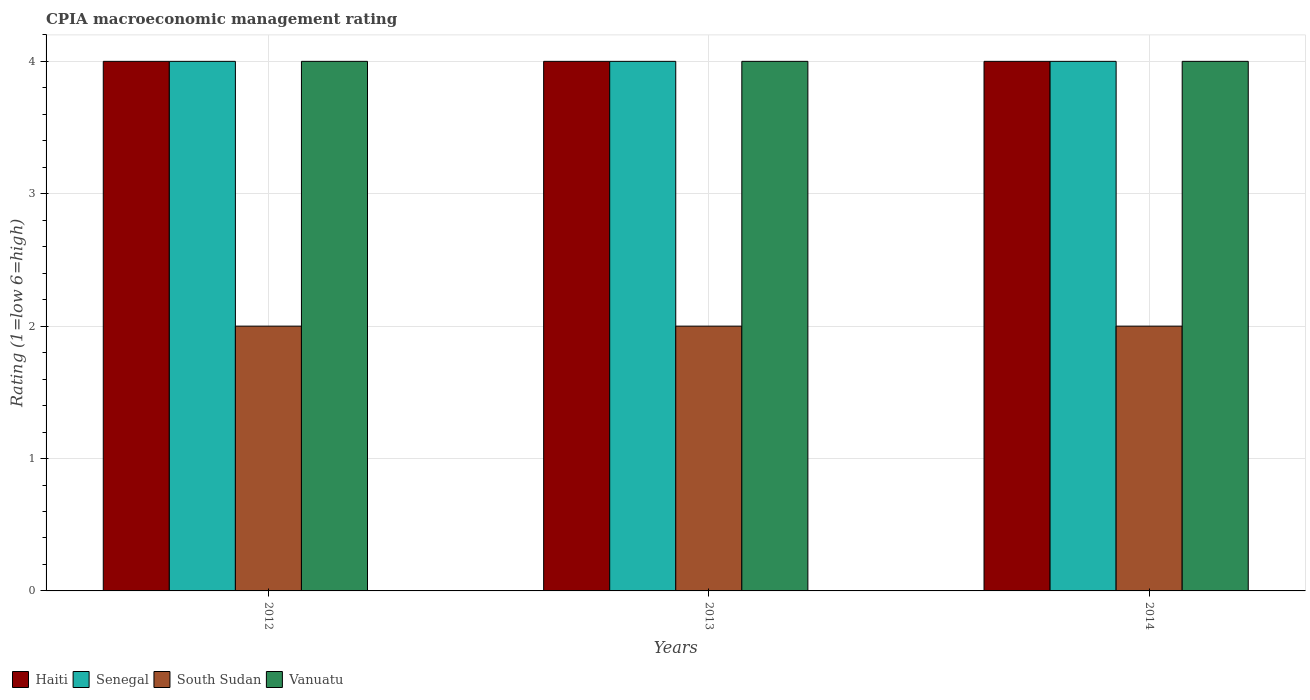Are the number of bars on each tick of the X-axis equal?
Provide a short and direct response. Yes. How many bars are there on the 2nd tick from the left?
Give a very brief answer. 4. In which year was the CPIA rating in Haiti maximum?
Provide a short and direct response. 2012. What is the total CPIA rating in Vanuatu in the graph?
Offer a terse response. 12. What is the average CPIA rating in Haiti per year?
Offer a very short reply. 4. In the year 2012, what is the difference between the CPIA rating in Haiti and CPIA rating in Senegal?
Provide a short and direct response. 0. What is the ratio of the CPIA rating in Haiti in 2012 to that in 2014?
Make the answer very short. 1. Is the CPIA rating in South Sudan in 2013 less than that in 2014?
Offer a terse response. No. Is the difference between the CPIA rating in Haiti in 2012 and 2014 greater than the difference between the CPIA rating in Senegal in 2012 and 2014?
Offer a terse response. No. What is the difference between the highest and the lowest CPIA rating in Vanuatu?
Make the answer very short. 0. In how many years, is the CPIA rating in Senegal greater than the average CPIA rating in Senegal taken over all years?
Offer a terse response. 0. Is the sum of the CPIA rating in South Sudan in 2012 and 2014 greater than the maximum CPIA rating in Haiti across all years?
Provide a succinct answer. No. What does the 1st bar from the left in 2014 represents?
Keep it short and to the point. Haiti. What does the 1st bar from the right in 2013 represents?
Your answer should be compact. Vanuatu. How many years are there in the graph?
Give a very brief answer. 3. Does the graph contain any zero values?
Give a very brief answer. No. Does the graph contain grids?
Give a very brief answer. Yes. How are the legend labels stacked?
Provide a short and direct response. Horizontal. What is the title of the graph?
Offer a very short reply. CPIA macroeconomic management rating. What is the label or title of the X-axis?
Offer a very short reply. Years. What is the label or title of the Y-axis?
Make the answer very short. Rating (1=low 6=high). What is the Rating (1=low 6=high) of Haiti in 2012?
Ensure brevity in your answer.  4. What is the Rating (1=low 6=high) in South Sudan in 2012?
Provide a succinct answer. 2. What is the Rating (1=low 6=high) of South Sudan in 2013?
Provide a short and direct response. 2. What is the Rating (1=low 6=high) of Vanuatu in 2013?
Ensure brevity in your answer.  4. What is the Rating (1=low 6=high) of Senegal in 2014?
Provide a short and direct response. 4. What is the Rating (1=low 6=high) of South Sudan in 2014?
Provide a short and direct response. 2. Across all years, what is the maximum Rating (1=low 6=high) of Vanuatu?
Your answer should be compact. 4. Across all years, what is the minimum Rating (1=low 6=high) of Senegal?
Provide a succinct answer. 4. Across all years, what is the minimum Rating (1=low 6=high) in South Sudan?
Your answer should be compact. 2. What is the total Rating (1=low 6=high) of Haiti in the graph?
Provide a succinct answer. 12. What is the total Rating (1=low 6=high) of South Sudan in the graph?
Keep it short and to the point. 6. What is the difference between the Rating (1=low 6=high) in Haiti in 2012 and that in 2013?
Your answer should be compact. 0. What is the difference between the Rating (1=low 6=high) in South Sudan in 2012 and that in 2013?
Your response must be concise. 0. What is the difference between the Rating (1=low 6=high) of Vanuatu in 2012 and that in 2013?
Your response must be concise. 0. What is the difference between the Rating (1=low 6=high) in Haiti in 2012 and that in 2014?
Keep it short and to the point. 0. What is the difference between the Rating (1=low 6=high) in Senegal in 2012 and that in 2014?
Ensure brevity in your answer.  0. What is the difference between the Rating (1=low 6=high) of South Sudan in 2012 and that in 2014?
Provide a succinct answer. 0. What is the difference between the Rating (1=low 6=high) in Haiti in 2013 and that in 2014?
Provide a succinct answer. 0. What is the difference between the Rating (1=low 6=high) of South Sudan in 2013 and that in 2014?
Offer a terse response. 0. What is the difference between the Rating (1=low 6=high) of Vanuatu in 2013 and that in 2014?
Your response must be concise. 0. What is the difference between the Rating (1=low 6=high) of Haiti in 2012 and the Rating (1=low 6=high) of Senegal in 2013?
Provide a short and direct response. 0. What is the difference between the Rating (1=low 6=high) in Senegal in 2012 and the Rating (1=low 6=high) in South Sudan in 2013?
Ensure brevity in your answer.  2. What is the difference between the Rating (1=low 6=high) of Senegal in 2012 and the Rating (1=low 6=high) of Vanuatu in 2013?
Your answer should be very brief. 0. What is the difference between the Rating (1=low 6=high) in South Sudan in 2012 and the Rating (1=low 6=high) in Vanuatu in 2013?
Provide a succinct answer. -2. What is the difference between the Rating (1=low 6=high) in Senegal in 2012 and the Rating (1=low 6=high) in Vanuatu in 2014?
Ensure brevity in your answer.  0. What is the difference between the Rating (1=low 6=high) of South Sudan in 2012 and the Rating (1=low 6=high) of Vanuatu in 2014?
Your answer should be compact. -2. What is the difference between the Rating (1=low 6=high) of Haiti in 2013 and the Rating (1=low 6=high) of South Sudan in 2014?
Give a very brief answer. 2. What is the average Rating (1=low 6=high) in Senegal per year?
Your response must be concise. 4. In the year 2012, what is the difference between the Rating (1=low 6=high) in Haiti and Rating (1=low 6=high) in Senegal?
Your answer should be compact. 0. In the year 2012, what is the difference between the Rating (1=low 6=high) in Haiti and Rating (1=low 6=high) in South Sudan?
Offer a terse response. 2. In the year 2012, what is the difference between the Rating (1=low 6=high) of Haiti and Rating (1=low 6=high) of Vanuatu?
Your answer should be very brief. 0. In the year 2012, what is the difference between the Rating (1=low 6=high) in South Sudan and Rating (1=low 6=high) in Vanuatu?
Offer a terse response. -2. In the year 2013, what is the difference between the Rating (1=low 6=high) in Haiti and Rating (1=low 6=high) in Senegal?
Offer a terse response. 0. In the year 2013, what is the difference between the Rating (1=low 6=high) in Haiti and Rating (1=low 6=high) in South Sudan?
Provide a short and direct response. 2. In the year 2013, what is the difference between the Rating (1=low 6=high) in Senegal and Rating (1=low 6=high) in South Sudan?
Offer a very short reply. 2. In the year 2013, what is the difference between the Rating (1=low 6=high) of Senegal and Rating (1=low 6=high) of Vanuatu?
Offer a very short reply. 0. In the year 2013, what is the difference between the Rating (1=low 6=high) of South Sudan and Rating (1=low 6=high) of Vanuatu?
Make the answer very short. -2. In the year 2014, what is the difference between the Rating (1=low 6=high) in Haiti and Rating (1=low 6=high) in Senegal?
Offer a very short reply. 0. In the year 2014, what is the difference between the Rating (1=low 6=high) in Haiti and Rating (1=low 6=high) in Vanuatu?
Provide a succinct answer. 0. In the year 2014, what is the difference between the Rating (1=low 6=high) in Senegal and Rating (1=low 6=high) in Vanuatu?
Ensure brevity in your answer.  0. In the year 2014, what is the difference between the Rating (1=low 6=high) of South Sudan and Rating (1=low 6=high) of Vanuatu?
Offer a terse response. -2. What is the ratio of the Rating (1=low 6=high) of Haiti in 2012 to that in 2013?
Offer a terse response. 1. What is the ratio of the Rating (1=low 6=high) in Haiti in 2012 to that in 2014?
Offer a terse response. 1. What is the ratio of the Rating (1=low 6=high) of South Sudan in 2012 to that in 2014?
Ensure brevity in your answer.  1. What is the ratio of the Rating (1=low 6=high) in Vanuatu in 2012 to that in 2014?
Ensure brevity in your answer.  1. What is the ratio of the Rating (1=low 6=high) in Senegal in 2013 to that in 2014?
Your answer should be compact. 1. What is the ratio of the Rating (1=low 6=high) of South Sudan in 2013 to that in 2014?
Your response must be concise. 1. What is the ratio of the Rating (1=low 6=high) of Vanuatu in 2013 to that in 2014?
Give a very brief answer. 1. What is the difference between the highest and the second highest Rating (1=low 6=high) of Haiti?
Offer a terse response. 0. What is the difference between the highest and the second highest Rating (1=low 6=high) in South Sudan?
Offer a very short reply. 0. What is the difference between the highest and the second highest Rating (1=low 6=high) in Vanuatu?
Ensure brevity in your answer.  0. What is the difference between the highest and the lowest Rating (1=low 6=high) in South Sudan?
Offer a very short reply. 0. 